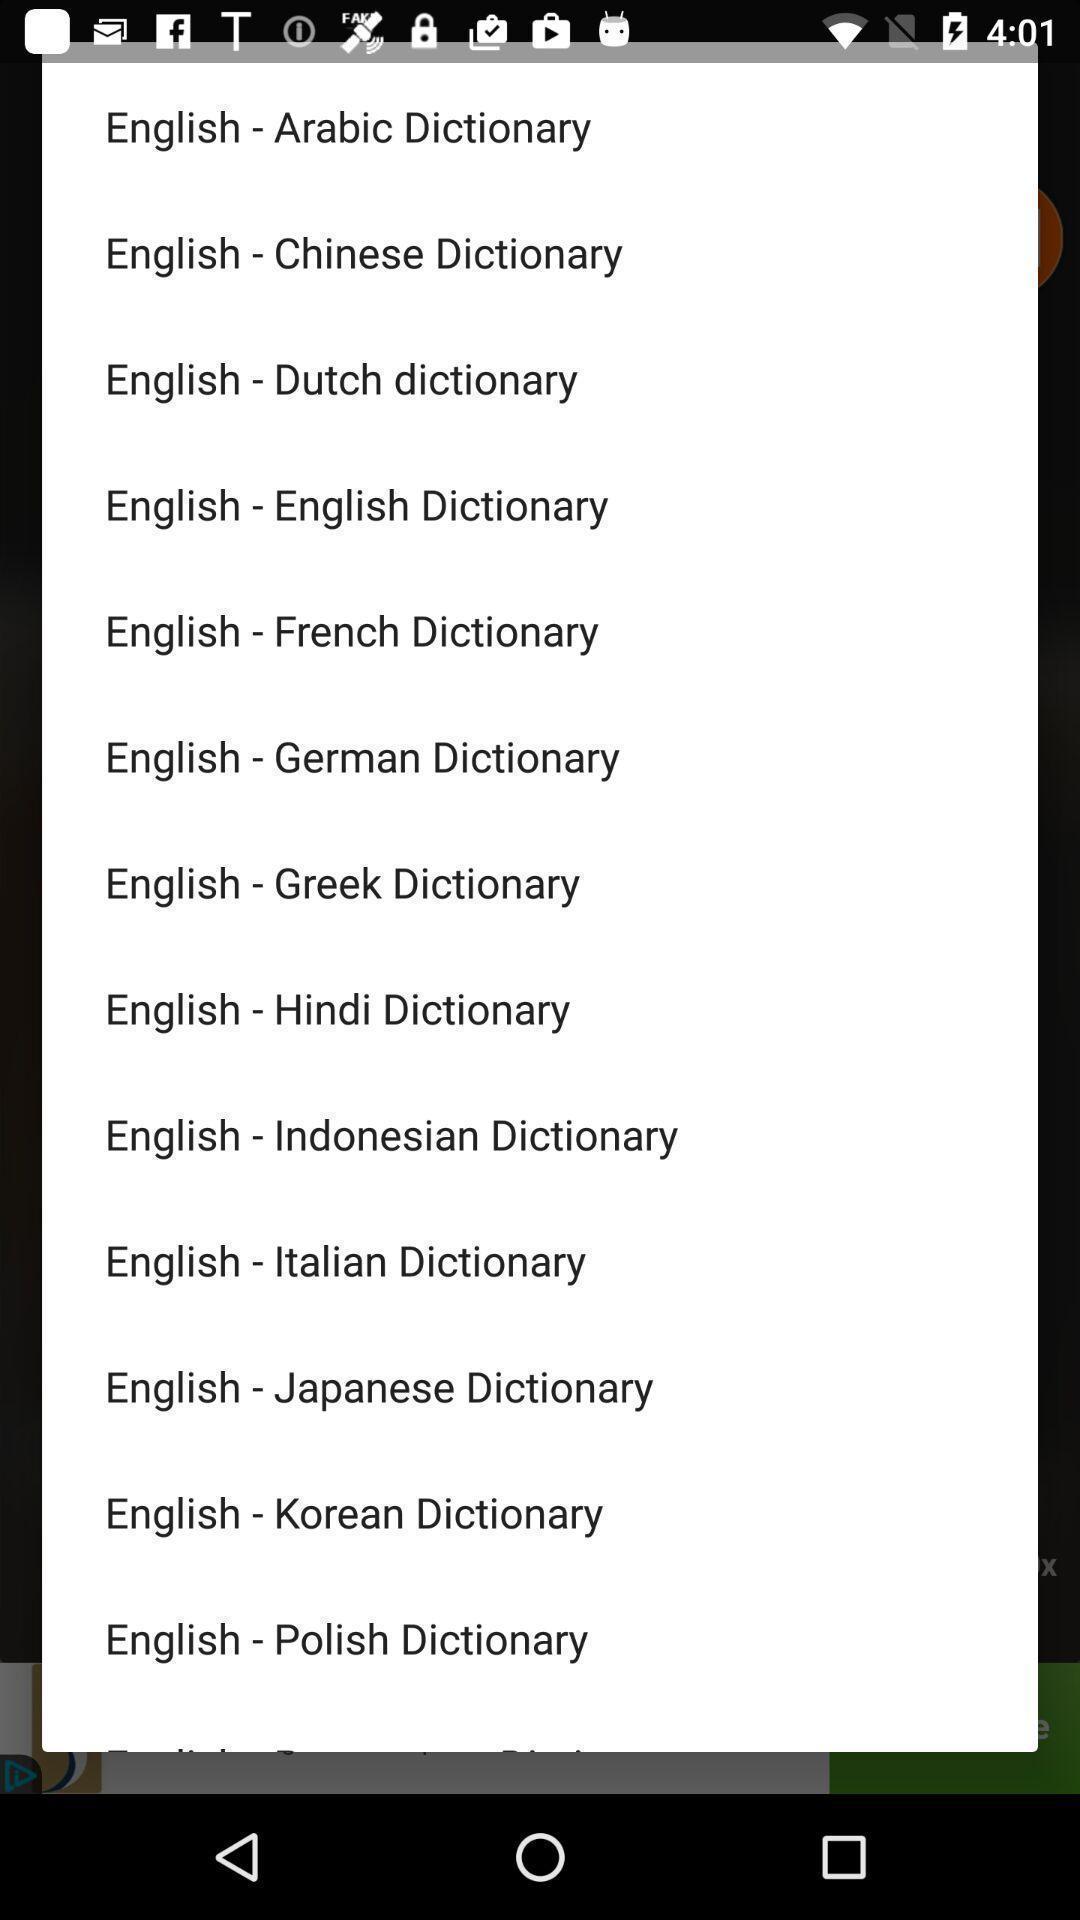Provide a detailed account of this screenshot. Pop-up window displaying many languages for translation. 